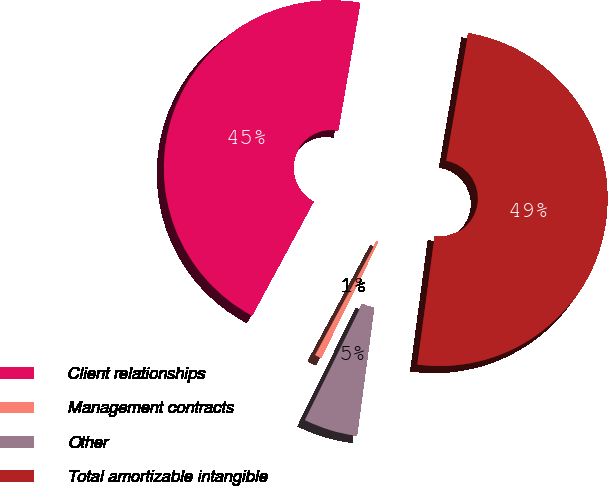<chart> <loc_0><loc_0><loc_500><loc_500><pie_chart><fcel>Client relationships<fcel>Management contracts<fcel>Other<fcel>Total amortizable intangible<nl><fcel>44.84%<fcel>0.6%<fcel>5.16%<fcel>49.4%<nl></chart> 